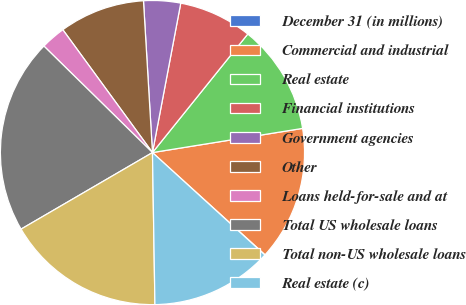Convert chart. <chart><loc_0><loc_0><loc_500><loc_500><pie_chart><fcel>December 31 (in millions)<fcel>Commercial and industrial<fcel>Real estate<fcel>Financial institutions<fcel>Government agencies<fcel>Other<fcel>Loans held-for-sale and at<fcel>Total US wholesale loans<fcel>Total non-US wholesale loans<fcel>Real estate (c)<nl><fcel>0.03%<fcel>14.27%<fcel>11.68%<fcel>7.8%<fcel>3.92%<fcel>9.09%<fcel>2.62%<fcel>20.74%<fcel>16.86%<fcel>12.98%<nl></chart> 